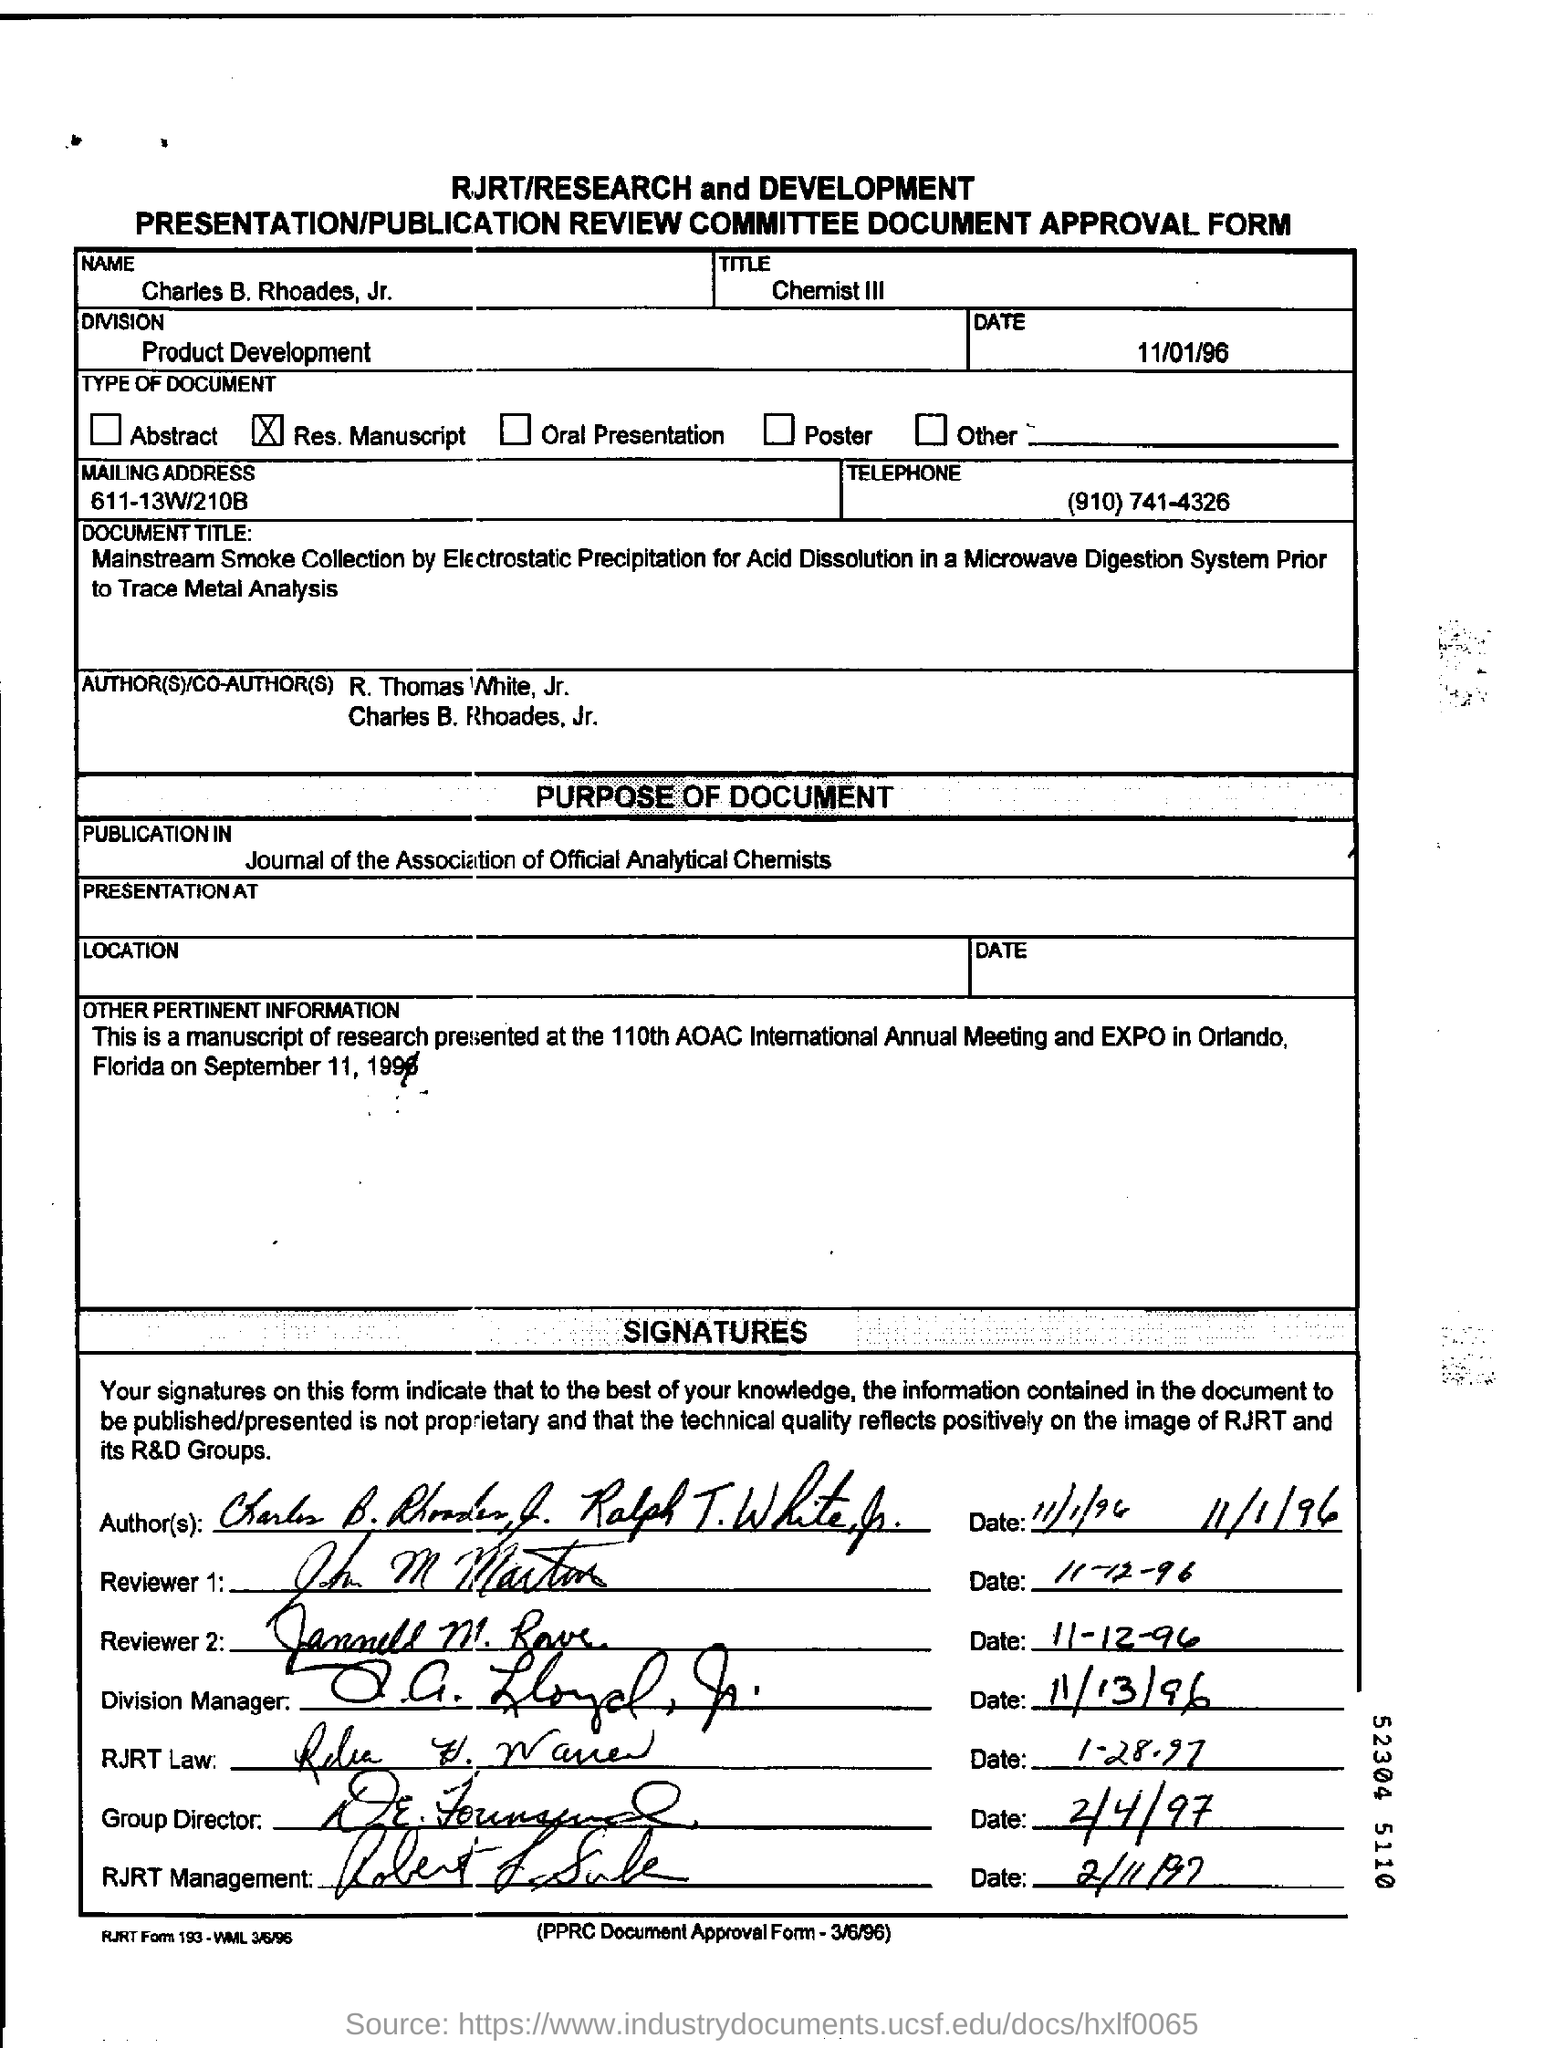What is the Name?
Give a very brief answer. Charles B. Rhoades, Jr. What is the Division?
Keep it short and to the point. Product Development. What is the Date?
Offer a very short reply. 11/01/96. What is the Mailing Address?
Provide a succinct answer. 611-13W/210B. 